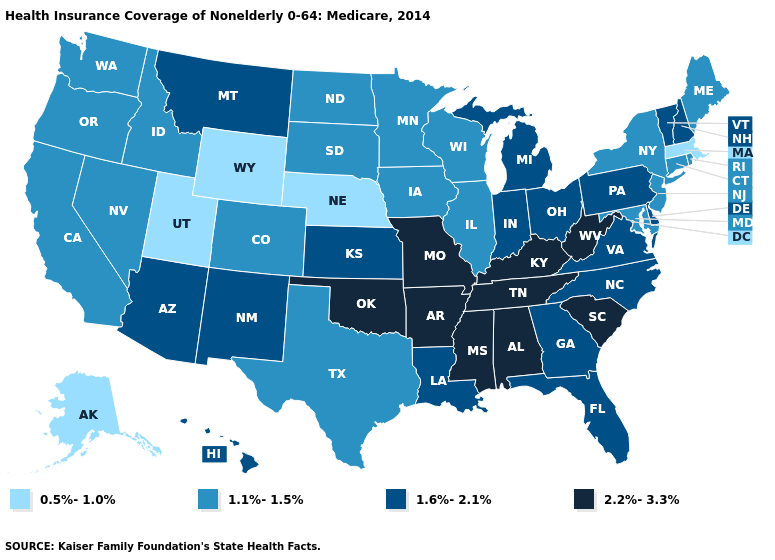Name the states that have a value in the range 1.1%-1.5%?
Concise answer only. California, Colorado, Connecticut, Idaho, Illinois, Iowa, Maine, Maryland, Minnesota, Nevada, New Jersey, New York, North Dakota, Oregon, Rhode Island, South Dakota, Texas, Washington, Wisconsin. What is the value of Louisiana?
Quick response, please. 1.6%-2.1%. What is the lowest value in the USA?
Give a very brief answer. 0.5%-1.0%. What is the value of Michigan?
Give a very brief answer. 1.6%-2.1%. What is the lowest value in the Northeast?
Keep it brief. 0.5%-1.0%. Name the states that have a value in the range 1.1%-1.5%?
Quick response, please. California, Colorado, Connecticut, Idaho, Illinois, Iowa, Maine, Maryland, Minnesota, Nevada, New Jersey, New York, North Dakota, Oregon, Rhode Island, South Dakota, Texas, Washington, Wisconsin. Name the states that have a value in the range 1.6%-2.1%?
Give a very brief answer. Arizona, Delaware, Florida, Georgia, Hawaii, Indiana, Kansas, Louisiana, Michigan, Montana, New Hampshire, New Mexico, North Carolina, Ohio, Pennsylvania, Vermont, Virginia. Does Minnesota have the highest value in the MidWest?
Give a very brief answer. No. What is the lowest value in the South?
Answer briefly. 1.1%-1.5%. What is the highest value in the USA?
Give a very brief answer. 2.2%-3.3%. Does the first symbol in the legend represent the smallest category?
Be succinct. Yes. Does Connecticut have the lowest value in the Northeast?
Short answer required. No. Name the states that have a value in the range 2.2%-3.3%?
Keep it brief. Alabama, Arkansas, Kentucky, Mississippi, Missouri, Oklahoma, South Carolina, Tennessee, West Virginia. What is the lowest value in states that border Kansas?
Keep it brief. 0.5%-1.0%. Name the states that have a value in the range 0.5%-1.0%?
Answer briefly. Alaska, Massachusetts, Nebraska, Utah, Wyoming. 